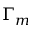Convert formula to latex. <formula><loc_0><loc_0><loc_500><loc_500>\Gamma _ { m }</formula> 